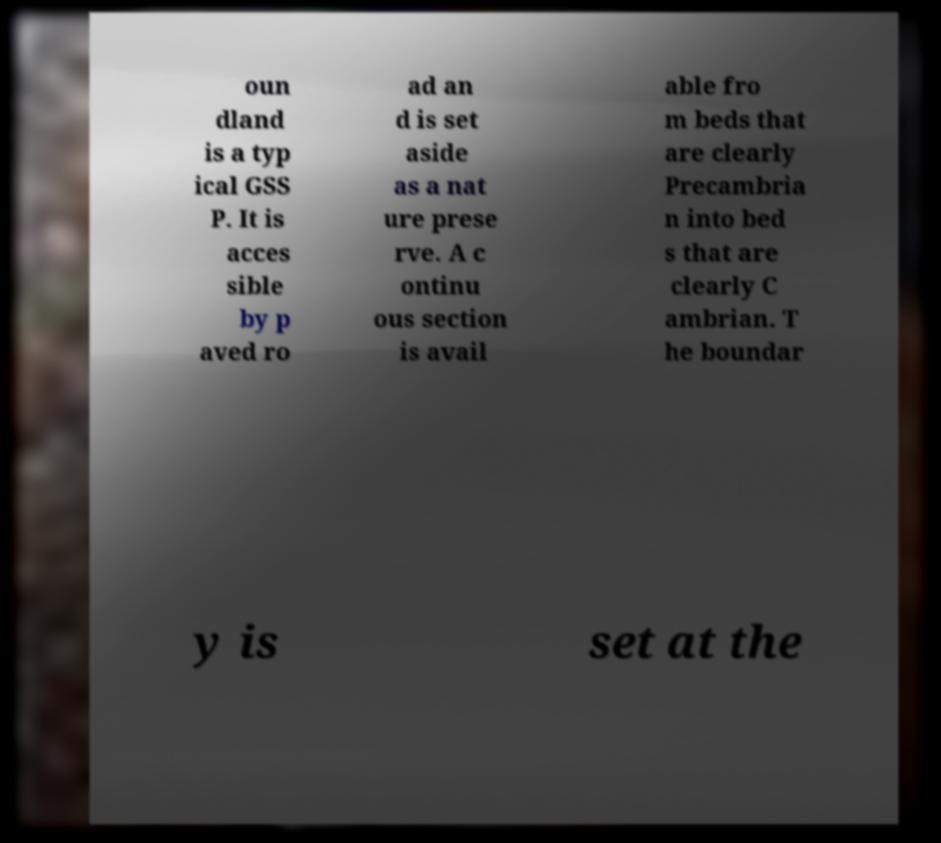For documentation purposes, I need the text within this image transcribed. Could you provide that? oun dland is a typ ical GSS P. It is acces sible by p aved ro ad an d is set aside as a nat ure prese rve. A c ontinu ous section is avail able fro m beds that are clearly Precambria n into bed s that are clearly C ambrian. T he boundar y is set at the 